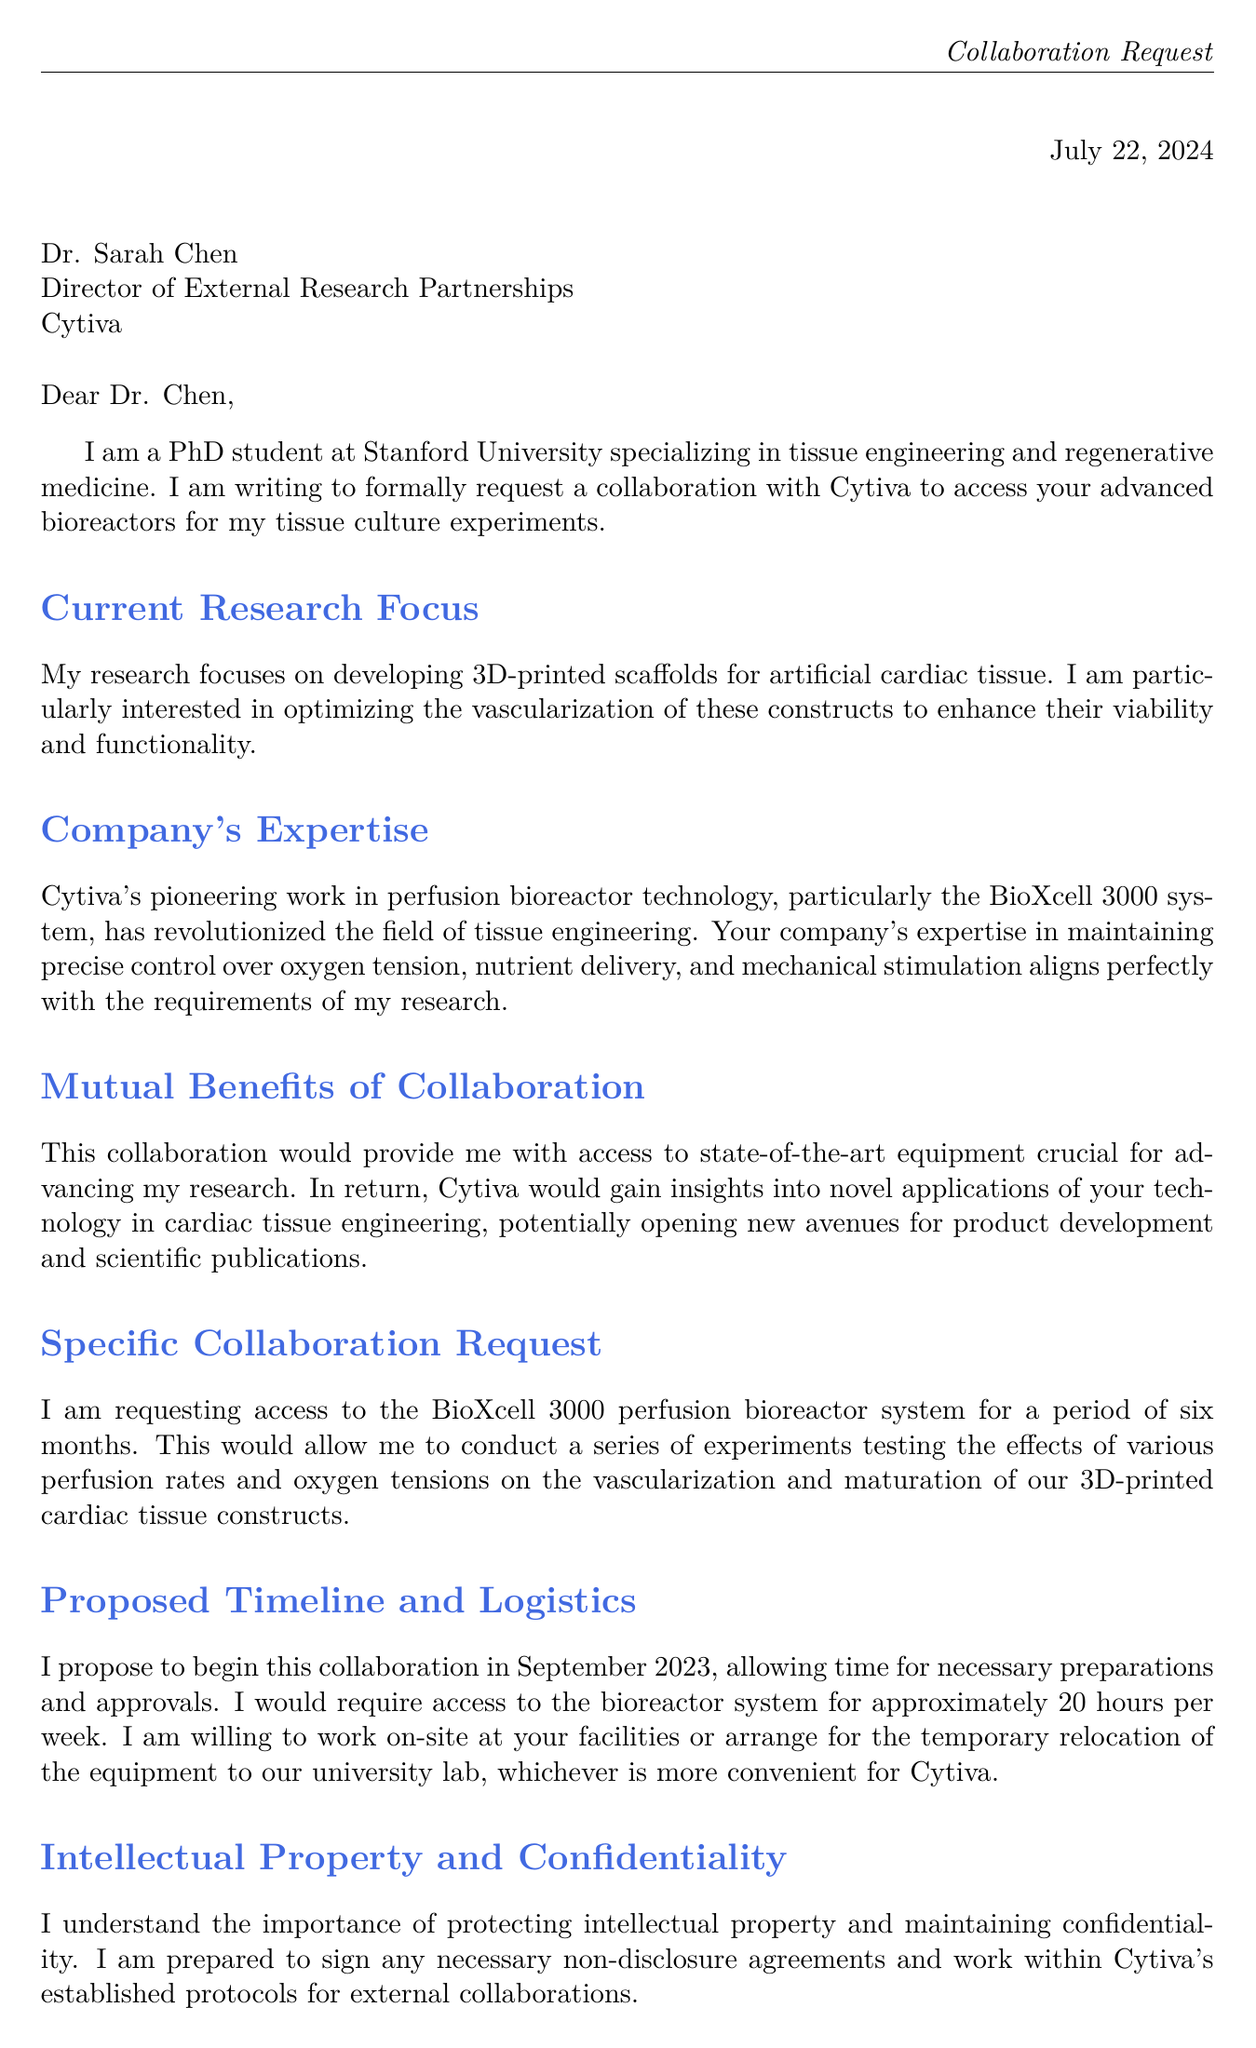What is the name of the recipient? The recipient is Dr. Sarah Chen, as stated in the salutation of the letter.
Answer: Dr. Sarah Chen What is the name of the company? The company mentioned in the letter is Cytiva, as indicated throughout the document.
Answer: Cytiva What is the bioreactor model requested for access? The specific bioreactor system requested is the BioXcell 3000, mentioned in the specific collaboration request.
Answer: BioXcell 3000 How many hours per week is access to the bioreactor requested? The letter specifies a requirement of approximately 20 hours per week for access to the bioreactor.
Answer: 20 hours What is the proposed start month for the collaboration? The proposed start month indicated in the logistics section of the letter is September 2023.
Answer: September 2023 What is the main research focus of the PhD student? The main research focus is on developing 3D-printed scaffolds for artificial cardiac tissue, as described in the research focus section.
Answer: 3D-printed scaffolds for artificial cardiac tissue What is a potential benefit of the collaboration for the company? A potential benefit for Cytiva is gaining insights into novel applications of their technology in cardiac tissue engineering.
Answer: Insights into novel applications What does the student agree to in terms of confidentiality? The student agrees to sign any necessary non-disclosure agreements and work within Cytiva's established protocols for external collaborations.
Answer: Sign non-disclosure agreements What is the purpose of the letter? The purpose of the letter is to formally request a collaboration to access advanced bioreactors for tissue culture experiments.
Answer: Request a collaboration 